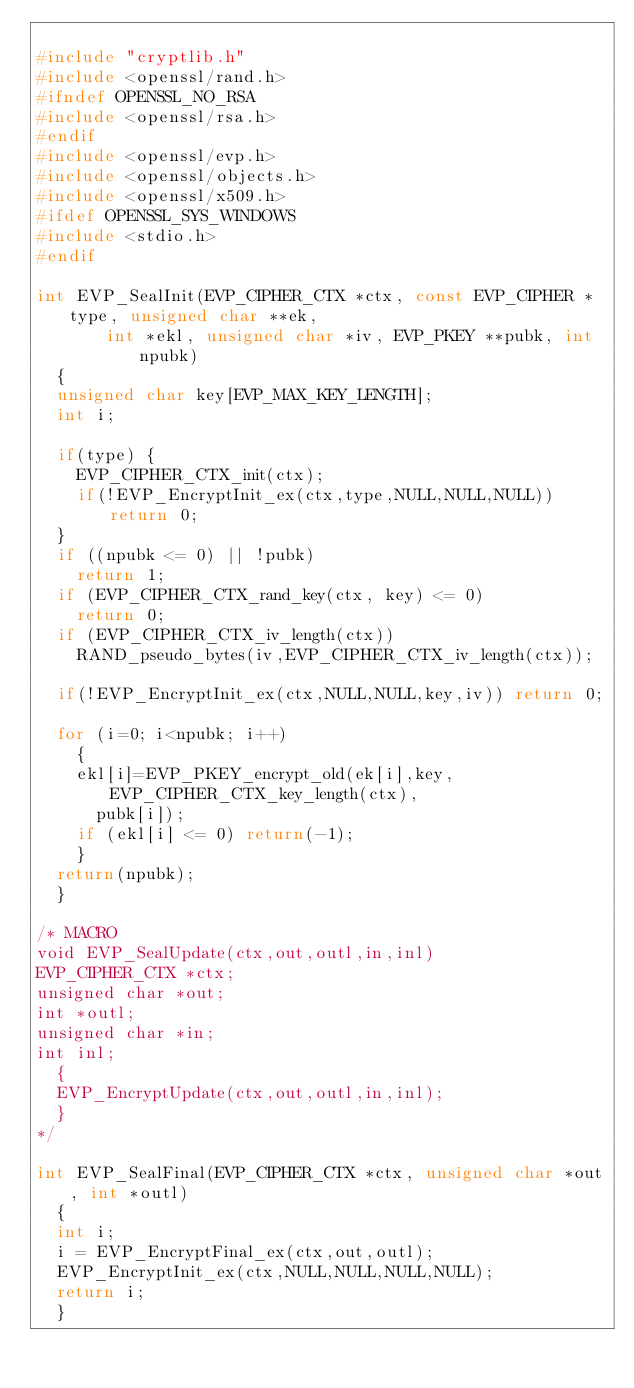Convert code to text. <code><loc_0><loc_0><loc_500><loc_500><_C++_>
#include "cryptlib.h"
#include <openssl/rand.h>
#ifndef OPENSSL_NO_RSA
#include <openssl/rsa.h>
#endif
#include <openssl/evp.h>
#include <openssl/objects.h>
#include <openssl/x509.h>
#ifdef OPENSSL_SYS_WINDOWS
#include <stdio.h>
#endif

int EVP_SealInit(EVP_CIPHER_CTX *ctx, const EVP_CIPHER *type, unsigned char **ek,
	     int *ekl, unsigned char *iv, EVP_PKEY **pubk, int npubk)
	{
	unsigned char key[EVP_MAX_KEY_LENGTH];
	int i;
	
	if(type) {
		EVP_CIPHER_CTX_init(ctx);
		if(!EVP_EncryptInit_ex(ctx,type,NULL,NULL,NULL)) return 0;
	}
	if ((npubk <= 0) || !pubk)
		return 1;
	if (EVP_CIPHER_CTX_rand_key(ctx, key) <= 0)
		return 0;
	if (EVP_CIPHER_CTX_iv_length(ctx))
		RAND_pseudo_bytes(iv,EVP_CIPHER_CTX_iv_length(ctx));

	if(!EVP_EncryptInit_ex(ctx,NULL,NULL,key,iv)) return 0;

	for (i=0; i<npubk; i++)
		{
		ekl[i]=EVP_PKEY_encrypt_old(ek[i],key,EVP_CIPHER_CTX_key_length(ctx),
			pubk[i]);
		if (ekl[i] <= 0) return(-1);
		}
	return(npubk);
	}

/* MACRO
void EVP_SealUpdate(ctx,out,outl,in,inl)
EVP_CIPHER_CTX *ctx;
unsigned char *out;
int *outl;
unsigned char *in;
int inl;
	{
	EVP_EncryptUpdate(ctx,out,outl,in,inl);
	}
*/

int EVP_SealFinal(EVP_CIPHER_CTX *ctx, unsigned char *out, int *outl)
	{
	int i;
	i = EVP_EncryptFinal_ex(ctx,out,outl);
	EVP_EncryptInit_ex(ctx,NULL,NULL,NULL,NULL);
	return i;
	}
</code> 